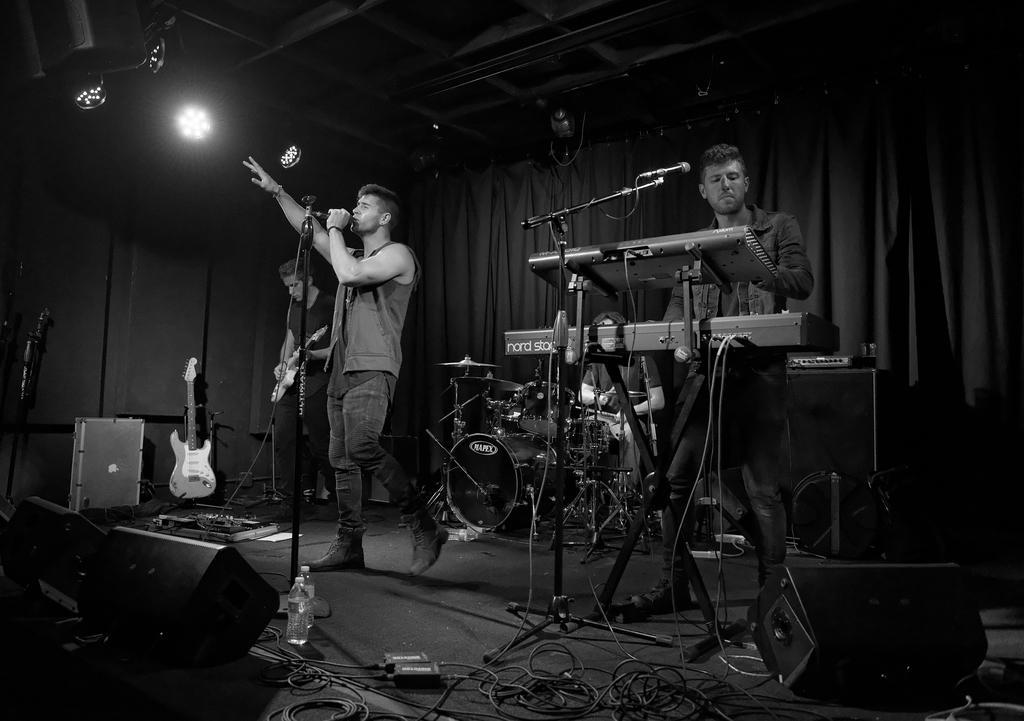In one or two sentences, can you explain what this image depicts? This is a black and white image. In this image we can see three men standing on the stage. In that a man is holding a mic with a stand and the other is holding a guitar. We can also see some musical instruments, wires, speaker boxes, a mic with a stand, some bottles and a person sitting on a chair holding some sticks on the stage. On the backside we can see a curtain and some lights to a roof. 